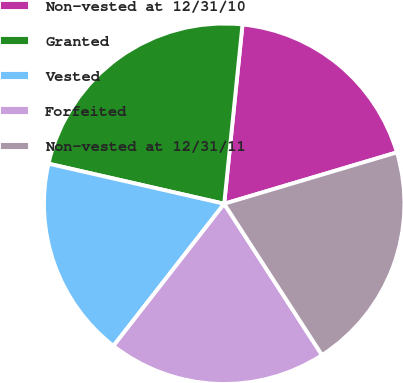Convert chart. <chart><loc_0><loc_0><loc_500><loc_500><pie_chart><fcel>Non-vested at 12/31/10<fcel>Granted<fcel>Vested<fcel>Forfeited<fcel>Non-vested at 12/31/11<nl><fcel>18.78%<fcel>23.05%<fcel>18.04%<fcel>19.67%<fcel>20.47%<nl></chart> 